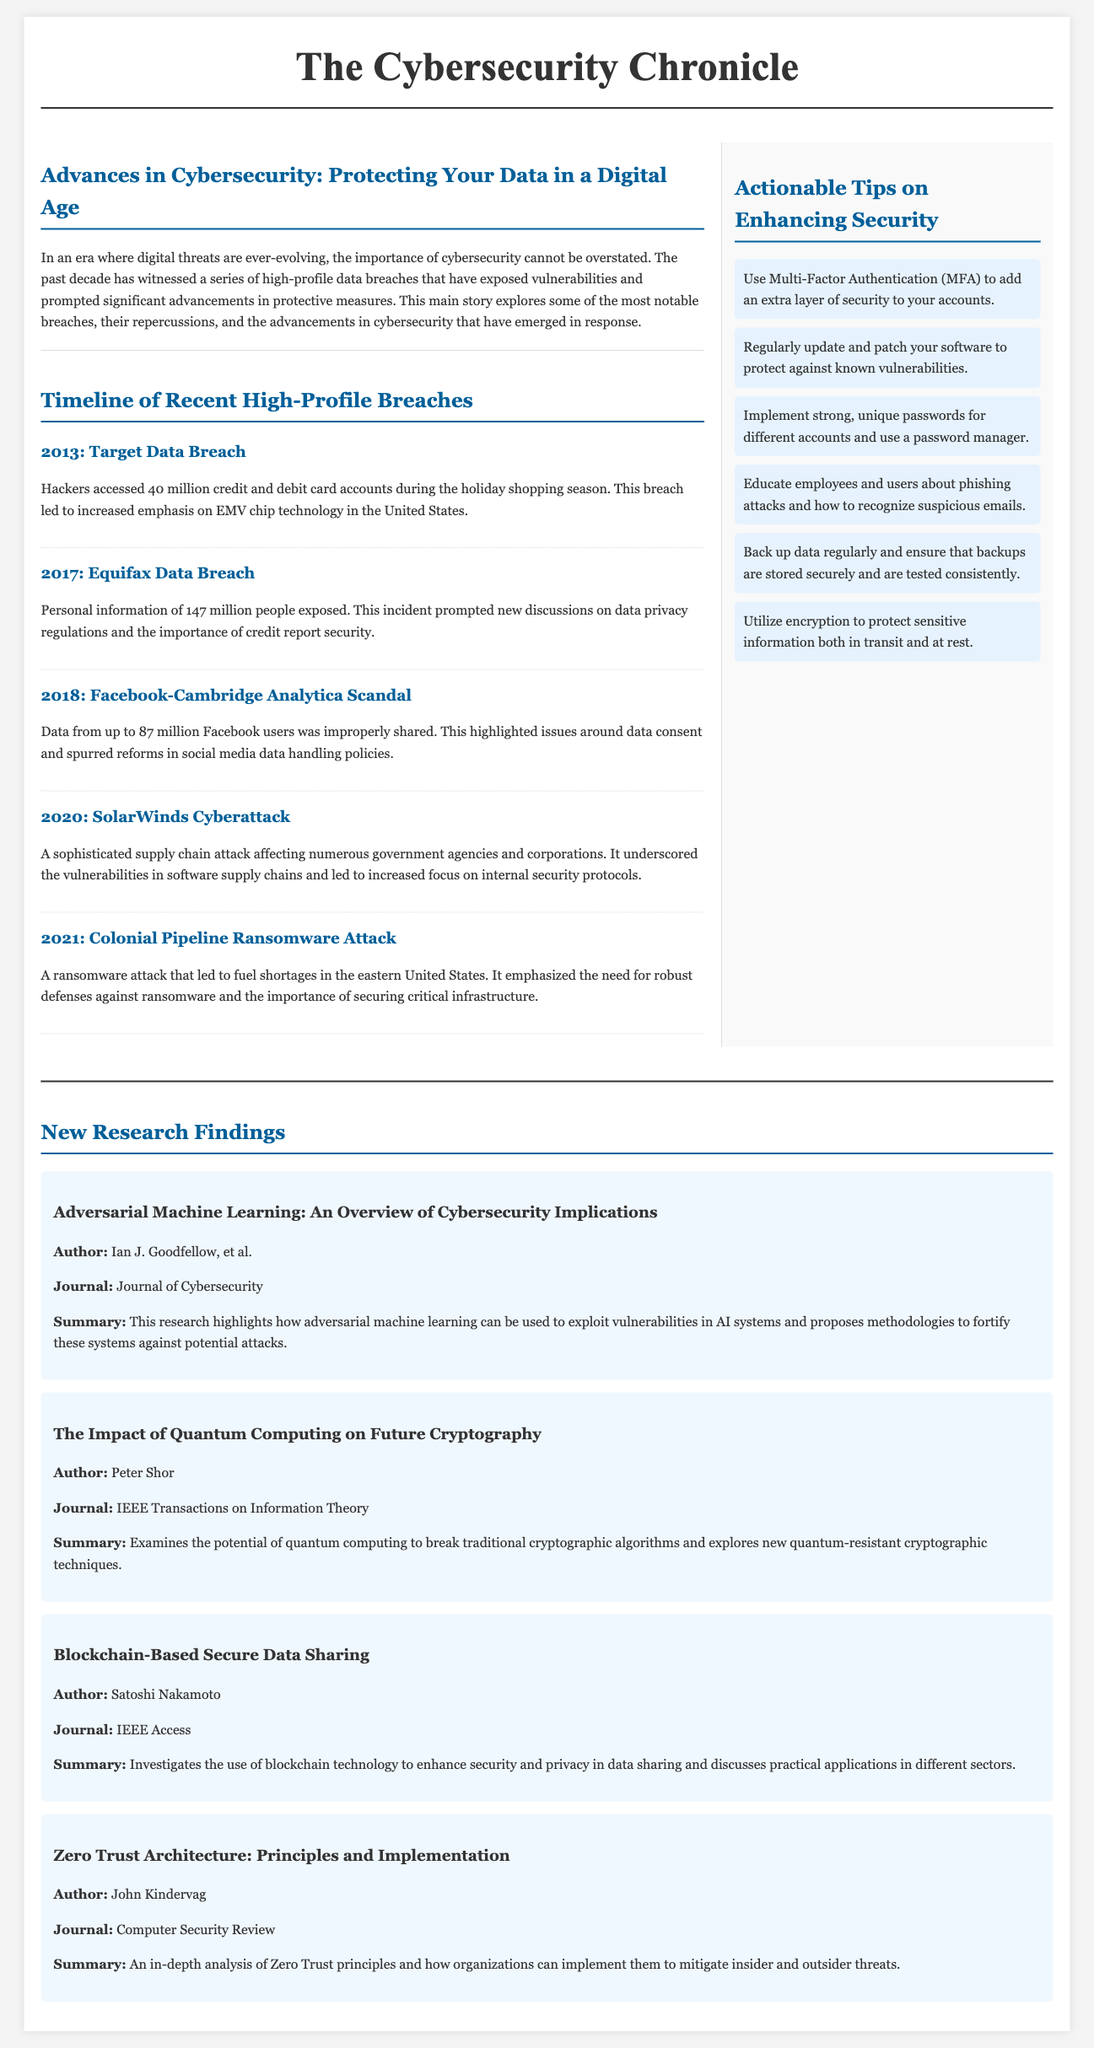What is the main topic of the article? The main topic is outlined in the title of the article "Advances in Cybersecurity: Protecting Your Data in a Digital Age."
Answer: Advances in Cybersecurity How many high-profile breaches are listed in the timeline? The timeline includes a total of five significant breaches mentioned.
Answer: Five What year did the Colonial Pipeline ransomware attack occur? The date of the Colonial Pipeline ransomware attack is specified as 2021.
Answer: 2021 Which publication discusses Zero Trust Architecture? The publication that discusses Zero Trust Architecture is titled "Zero Trust Architecture: Principles and Implementation."
Answer: Zero Trust Architecture: Principles and Implementation Who is the author of the research on Quantum Computing? The author of the paper "The Impact of Quantum Computing on Future Cryptography" is identified as Peter Shor.
Answer: Peter Shor What is one of the actionable tips for enhancing security? One of the tips includes implementing strong, unique passwords for different accounts.
Answer: Implement strong, unique passwords What incident prompted increased emphasis on EMV chip technology in the U.S.? The incident that led to increased emphasis on EMV chip technology was the Target Data Breach.
Answer: Target Data Breach What is the title of the first research publication mentioned? The title of the first research publication is "Adversarial Machine Learning: An Overview of Cybersecurity Implications."
Answer: Adversarial Machine Learning: An Overview of Cybersecurity Implications How many issues does the article highlight regarding data consent? The article specifically highlights one major issue regarding data consent which arose from the Facebook-Cambridge Analytica scandal.
Answer: One 